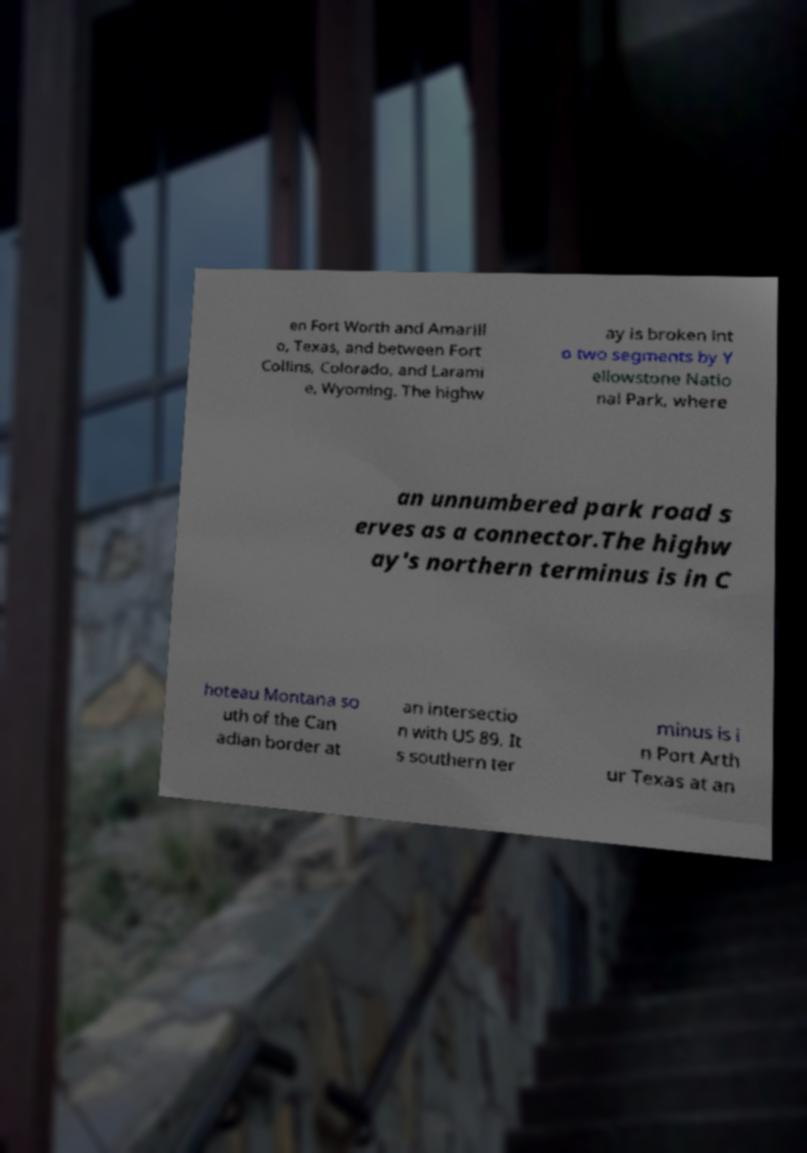What messages or text are displayed in this image? I need them in a readable, typed format. en Fort Worth and Amarill o, Texas, and between Fort Collins, Colorado, and Larami e, Wyoming. The highw ay is broken int o two segments by Y ellowstone Natio nal Park, where an unnumbered park road s erves as a connector.The highw ay's northern terminus is in C hoteau Montana so uth of the Can adian border at an intersectio n with US 89. It s southern ter minus is i n Port Arth ur Texas at an 